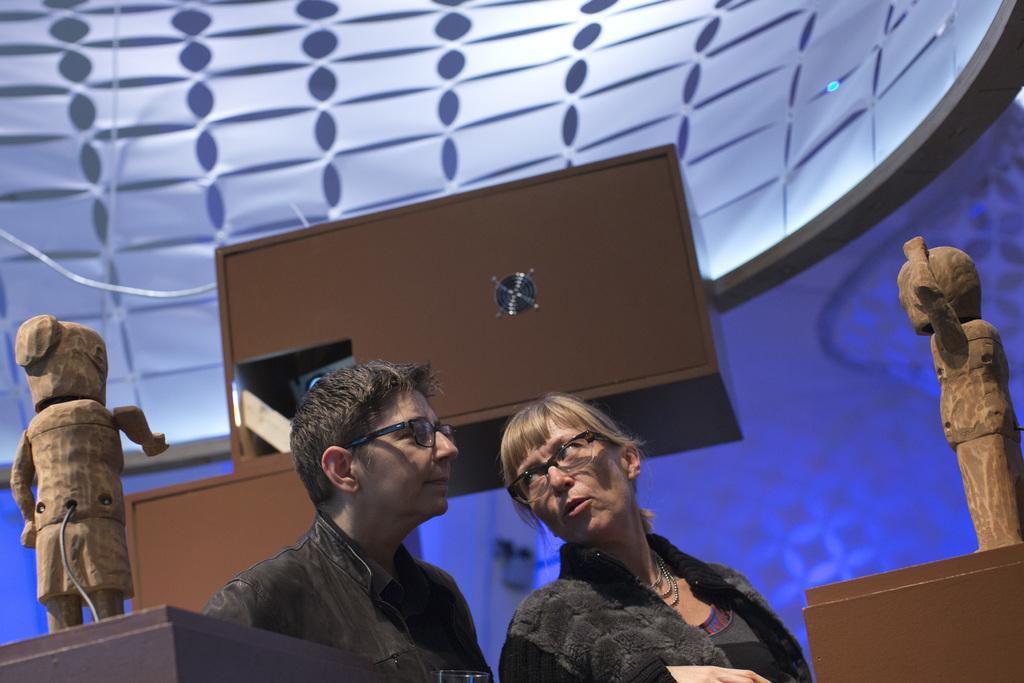Can you describe this image briefly? In this image there is a woman turned behind and speaking to a man, in front of the woman and behind the man there are two dolls on the table, behind them there is a wooden cupboard. 